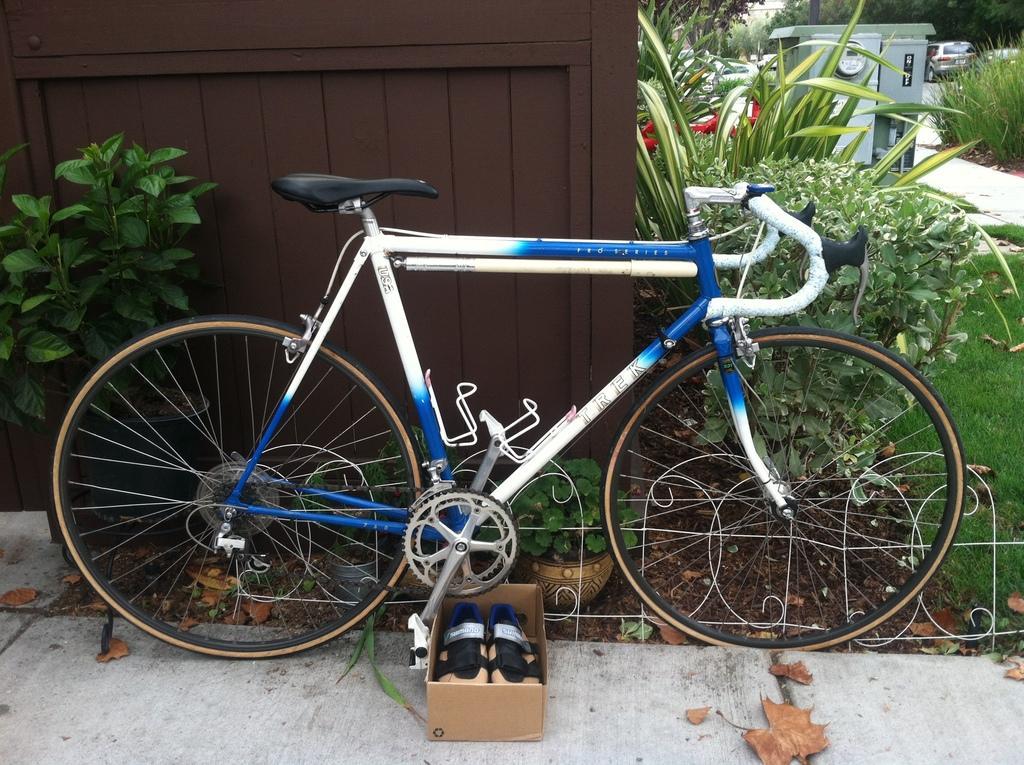In one or two sentences, can you explain what this image depicts? In this picture we can see a bicycle, house plants, box with footwear in it, dried leaves on the ground and in the background we can see the grass, plants, vehicles, trees and some objects. 